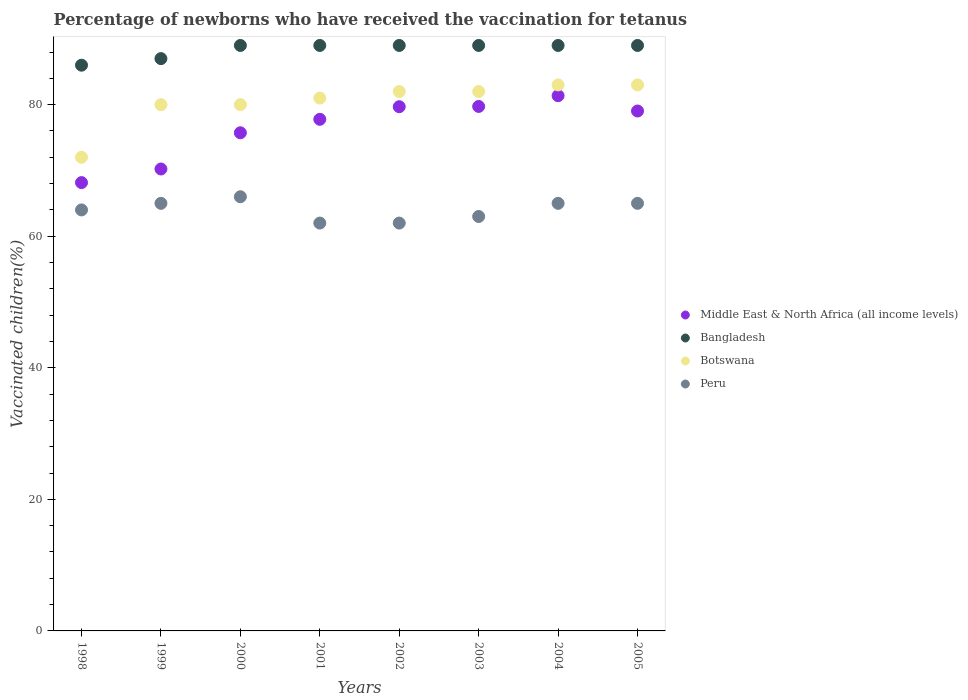What is the percentage of vaccinated children in Botswana in 2003?
Make the answer very short. 82. Across all years, what is the maximum percentage of vaccinated children in Bangladesh?
Make the answer very short. 89. Across all years, what is the minimum percentage of vaccinated children in Botswana?
Offer a terse response. 72. In which year was the percentage of vaccinated children in Peru maximum?
Make the answer very short. 2000. What is the total percentage of vaccinated children in Peru in the graph?
Your answer should be very brief. 512. What is the average percentage of vaccinated children in Peru per year?
Your response must be concise. 64. In the year 1999, what is the difference between the percentage of vaccinated children in Middle East & North Africa (all income levels) and percentage of vaccinated children in Bangladesh?
Give a very brief answer. -16.78. In how many years, is the percentage of vaccinated children in Middle East & North Africa (all income levels) greater than 64 %?
Provide a succinct answer. 8. What is the ratio of the percentage of vaccinated children in Middle East & North Africa (all income levels) in 2001 to that in 2005?
Provide a succinct answer. 0.98. Is the difference between the percentage of vaccinated children in Middle East & North Africa (all income levels) in 2000 and 2005 greater than the difference between the percentage of vaccinated children in Bangladesh in 2000 and 2005?
Provide a short and direct response. No. What is the difference between the highest and the lowest percentage of vaccinated children in Bangladesh?
Your response must be concise. 3. In how many years, is the percentage of vaccinated children in Peru greater than the average percentage of vaccinated children in Peru taken over all years?
Provide a short and direct response. 4. Does the percentage of vaccinated children in Botswana monotonically increase over the years?
Make the answer very short. No. Is the percentage of vaccinated children in Middle East & North Africa (all income levels) strictly less than the percentage of vaccinated children in Peru over the years?
Your answer should be very brief. No. How many dotlines are there?
Provide a short and direct response. 4. What is the difference between two consecutive major ticks on the Y-axis?
Provide a succinct answer. 20. Are the values on the major ticks of Y-axis written in scientific E-notation?
Your answer should be very brief. No. Where does the legend appear in the graph?
Ensure brevity in your answer.  Center right. How many legend labels are there?
Offer a very short reply. 4. What is the title of the graph?
Make the answer very short. Percentage of newborns who have received the vaccination for tetanus. Does "Ecuador" appear as one of the legend labels in the graph?
Provide a succinct answer. No. What is the label or title of the X-axis?
Offer a terse response. Years. What is the label or title of the Y-axis?
Your answer should be compact. Vaccinated children(%). What is the Vaccinated children(%) of Middle East & North Africa (all income levels) in 1998?
Your answer should be compact. 68.15. What is the Vaccinated children(%) in Peru in 1998?
Provide a succinct answer. 64. What is the Vaccinated children(%) in Middle East & North Africa (all income levels) in 1999?
Provide a succinct answer. 70.22. What is the Vaccinated children(%) in Bangladesh in 1999?
Give a very brief answer. 87. What is the Vaccinated children(%) of Middle East & North Africa (all income levels) in 2000?
Provide a succinct answer. 75.73. What is the Vaccinated children(%) of Bangladesh in 2000?
Your answer should be compact. 89. What is the Vaccinated children(%) of Middle East & North Africa (all income levels) in 2001?
Ensure brevity in your answer.  77.77. What is the Vaccinated children(%) in Bangladesh in 2001?
Your answer should be very brief. 89. What is the Vaccinated children(%) of Botswana in 2001?
Provide a succinct answer. 81. What is the Vaccinated children(%) in Middle East & North Africa (all income levels) in 2002?
Keep it short and to the point. 79.69. What is the Vaccinated children(%) in Bangladesh in 2002?
Offer a terse response. 89. What is the Vaccinated children(%) in Botswana in 2002?
Your response must be concise. 82. What is the Vaccinated children(%) of Middle East & North Africa (all income levels) in 2003?
Provide a short and direct response. 79.73. What is the Vaccinated children(%) in Bangladesh in 2003?
Make the answer very short. 89. What is the Vaccinated children(%) in Middle East & North Africa (all income levels) in 2004?
Keep it short and to the point. 81.36. What is the Vaccinated children(%) in Bangladesh in 2004?
Your response must be concise. 89. What is the Vaccinated children(%) in Botswana in 2004?
Provide a succinct answer. 83. What is the Vaccinated children(%) in Middle East & North Africa (all income levels) in 2005?
Keep it short and to the point. 79.04. What is the Vaccinated children(%) in Bangladesh in 2005?
Make the answer very short. 89. What is the Vaccinated children(%) in Peru in 2005?
Keep it short and to the point. 65. Across all years, what is the maximum Vaccinated children(%) of Middle East & North Africa (all income levels)?
Offer a very short reply. 81.36. Across all years, what is the maximum Vaccinated children(%) of Bangladesh?
Your answer should be compact. 89. Across all years, what is the maximum Vaccinated children(%) of Peru?
Make the answer very short. 66. Across all years, what is the minimum Vaccinated children(%) in Middle East & North Africa (all income levels)?
Your answer should be very brief. 68.15. Across all years, what is the minimum Vaccinated children(%) in Botswana?
Offer a very short reply. 72. Across all years, what is the minimum Vaccinated children(%) in Peru?
Provide a succinct answer. 62. What is the total Vaccinated children(%) in Middle East & North Africa (all income levels) in the graph?
Offer a very short reply. 611.69. What is the total Vaccinated children(%) in Bangladesh in the graph?
Make the answer very short. 707. What is the total Vaccinated children(%) in Botswana in the graph?
Your answer should be compact. 643. What is the total Vaccinated children(%) of Peru in the graph?
Your answer should be compact. 512. What is the difference between the Vaccinated children(%) in Middle East & North Africa (all income levels) in 1998 and that in 1999?
Offer a very short reply. -2.07. What is the difference between the Vaccinated children(%) in Peru in 1998 and that in 1999?
Your answer should be very brief. -1. What is the difference between the Vaccinated children(%) of Middle East & North Africa (all income levels) in 1998 and that in 2000?
Provide a succinct answer. -7.57. What is the difference between the Vaccinated children(%) of Bangladesh in 1998 and that in 2000?
Keep it short and to the point. -3. What is the difference between the Vaccinated children(%) in Peru in 1998 and that in 2000?
Keep it short and to the point. -2. What is the difference between the Vaccinated children(%) of Middle East & North Africa (all income levels) in 1998 and that in 2001?
Offer a terse response. -9.62. What is the difference between the Vaccinated children(%) of Bangladesh in 1998 and that in 2001?
Offer a terse response. -3. What is the difference between the Vaccinated children(%) in Peru in 1998 and that in 2001?
Your answer should be very brief. 2. What is the difference between the Vaccinated children(%) of Middle East & North Africa (all income levels) in 1998 and that in 2002?
Keep it short and to the point. -11.54. What is the difference between the Vaccinated children(%) of Peru in 1998 and that in 2002?
Provide a short and direct response. 2. What is the difference between the Vaccinated children(%) of Middle East & North Africa (all income levels) in 1998 and that in 2003?
Keep it short and to the point. -11.58. What is the difference between the Vaccinated children(%) of Bangladesh in 1998 and that in 2003?
Ensure brevity in your answer.  -3. What is the difference between the Vaccinated children(%) in Peru in 1998 and that in 2003?
Give a very brief answer. 1. What is the difference between the Vaccinated children(%) in Middle East & North Africa (all income levels) in 1998 and that in 2004?
Keep it short and to the point. -13.21. What is the difference between the Vaccinated children(%) of Middle East & North Africa (all income levels) in 1998 and that in 2005?
Offer a terse response. -10.89. What is the difference between the Vaccinated children(%) in Bangladesh in 1998 and that in 2005?
Ensure brevity in your answer.  -3. What is the difference between the Vaccinated children(%) in Botswana in 1998 and that in 2005?
Offer a very short reply. -11. What is the difference between the Vaccinated children(%) in Middle East & North Africa (all income levels) in 1999 and that in 2000?
Give a very brief answer. -5.5. What is the difference between the Vaccinated children(%) in Bangladesh in 1999 and that in 2000?
Your answer should be very brief. -2. What is the difference between the Vaccinated children(%) in Peru in 1999 and that in 2000?
Your answer should be compact. -1. What is the difference between the Vaccinated children(%) in Middle East & North Africa (all income levels) in 1999 and that in 2001?
Provide a succinct answer. -7.55. What is the difference between the Vaccinated children(%) in Bangladesh in 1999 and that in 2001?
Offer a very short reply. -2. What is the difference between the Vaccinated children(%) of Botswana in 1999 and that in 2001?
Your answer should be compact. -1. What is the difference between the Vaccinated children(%) of Peru in 1999 and that in 2001?
Your response must be concise. 3. What is the difference between the Vaccinated children(%) of Middle East & North Africa (all income levels) in 1999 and that in 2002?
Give a very brief answer. -9.47. What is the difference between the Vaccinated children(%) of Bangladesh in 1999 and that in 2002?
Ensure brevity in your answer.  -2. What is the difference between the Vaccinated children(%) in Botswana in 1999 and that in 2002?
Your answer should be very brief. -2. What is the difference between the Vaccinated children(%) of Middle East & North Africa (all income levels) in 1999 and that in 2003?
Ensure brevity in your answer.  -9.51. What is the difference between the Vaccinated children(%) in Bangladesh in 1999 and that in 2003?
Make the answer very short. -2. What is the difference between the Vaccinated children(%) in Middle East & North Africa (all income levels) in 1999 and that in 2004?
Provide a succinct answer. -11.14. What is the difference between the Vaccinated children(%) in Bangladesh in 1999 and that in 2004?
Provide a short and direct response. -2. What is the difference between the Vaccinated children(%) in Botswana in 1999 and that in 2004?
Offer a terse response. -3. What is the difference between the Vaccinated children(%) of Peru in 1999 and that in 2004?
Your answer should be compact. 0. What is the difference between the Vaccinated children(%) of Middle East & North Africa (all income levels) in 1999 and that in 2005?
Your answer should be compact. -8.82. What is the difference between the Vaccinated children(%) in Botswana in 1999 and that in 2005?
Keep it short and to the point. -3. What is the difference between the Vaccinated children(%) of Peru in 1999 and that in 2005?
Give a very brief answer. 0. What is the difference between the Vaccinated children(%) in Middle East & North Africa (all income levels) in 2000 and that in 2001?
Give a very brief answer. -2.05. What is the difference between the Vaccinated children(%) in Bangladesh in 2000 and that in 2001?
Your answer should be very brief. 0. What is the difference between the Vaccinated children(%) in Middle East & North Africa (all income levels) in 2000 and that in 2002?
Make the answer very short. -3.96. What is the difference between the Vaccinated children(%) of Botswana in 2000 and that in 2002?
Offer a terse response. -2. What is the difference between the Vaccinated children(%) of Peru in 2000 and that in 2002?
Provide a short and direct response. 4. What is the difference between the Vaccinated children(%) in Middle East & North Africa (all income levels) in 2000 and that in 2003?
Your answer should be compact. -4. What is the difference between the Vaccinated children(%) in Bangladesh in 2000 and that in 2003?
Your response must be concise. 0. What is the difference between the Vaccinated children(%) in Middle East & North Africa (all income levels) in 2000 and that in 2004?
Keep it short and to the point. -5.64. What is the difference between the Vaccinated children(%) in Middle East & North Africa (all income levels) in 2000 and that in 2005?
Provide a succinct answer. -3.31. What is the difference between the Vaccinated children(%) of Bangladesh in 2000 and that in 2005?
Provide a short and direct response. 0. What is the difference between the Vaccinated children(%) in Botswana in 2000 and that in 2005?
Provide a short and direct response. -3. What is the difference between the Vaccinated children(%) of Peru in 2000 and that in 2005?
Your answer should be compact. 1. What is the difference between the Vaccinated children(%) of Middle East & North Africa (all income levels) in 2001 and that in 2002?
Your answer should be very brief. -1.92. What is the difference between the Vaccinated children(%) of Peru in 2001 and that in 2002?
Make the answer very short. 0. What is the difference between the Vaccinated children(%) in Middle East & North Africa (all income levels) in 2001 and that in 2003?
Provide a succinct answer. -1.96. What is the difference between the Vaccinated children(%) of Bangladesh in 2001 and that in 2003?
Offer a terse response. 0. What is the difference between the Vaccinated children(%) in Botswana in 2001 and that in 2003?
Provide a succinct answer. -1. What is the difference between the Vaccinated children(%) in Peru in 2001 and that in 2003?
Give a very brief answer. -1. What is the difference between the Vaccinated children(%) in Middle East & North Africa (all income levels) in 2001 and that in 2004?
Your response must be concise. -3.59. What is the difference between the Vaccinated children(%) in Bangladesh in 2001 and that in 2004?
Your answer should be compact. 0. What is the difference between the Vaccinated children(%) in Botswana in 2001 and that in 2004?
Offer a terse response. -2. What is the difference between the Vaccinated children(%) in Peru in 2001 and that in 2004?
Your answer should be very brief. -3. What is the difference between the Vaccinated children(%) of Middle East & North Africa (all income levels) in 2001 and that in 2005?
Offer a terse response. -1.26. What is the difference between the Vaccinated children(%) of Botswana in 2001 and that in 2005?
Provide a short and direct response. -2. What is the difference between the Vaccinated children(%) of Middle East & North Africa (all income levels) in 2002 and that in 2003?
Keep it short and to the point. -0.04. What is the difference between the Vaccinated children(%) in Bangladesh in 2002 and that in 2003?
Your answer should be very brief. 0. What is the difference between the Vaccinated children(%) of Middle East & North Africa (all income levels) in 2002 and that in 2004?
Provide a succinct answer. -1.68. What is the difference between the Vaccinated children(%) in Bangladesh in 2002 and that in 2004?
Your answer should be very brief. 0. What is the difference between the Vaccinated children(%) in Peru in 2002 and that in 2004?
Provide a succinct answer. -3. What is the difference between the Vaccinated children(%) of Middle East & North Africa (all income levels) in 2002 and that in 2005?
Your response must be concise. 0.65. What is the difference between the Vaccinated children(%) of Bangladesh in 2002 and that in 2005?
Your answer should be compact. 0. What is the difference between the Vaccinated children(%) in Botswana in 2002 and that in 2005?
Offer a very short reply. -1. What is the difference between the Vaccinated children(%) of Peru in 2002 and that in 2005?
Ensure brevity in your answer.  -3. What is the difference between the Vaccinated children(%) of Middle East & North Africa (all income levels) in 2003 and that in 2004?
Ensure brevity in your answer.  -1.64. What is the difference between the Vaccinated children(%) in Botswana in 2003 and that in 2004?
Offer a terse response. -1. What is the difference between the Vaccinated children(%) of Peru in 2003 and that in 2004?
Offer a very short reply. -2. What is the difference between the Vaccinated children(%) in Middle East & North Africa (all income levels) in 2003 and that in 2005?
Your response must be concise. 0.69. What is the difference between the Vaccinated children(%) of Bangladesh in 2003 and that in 2005?
Keep it short and to the point. 0. What is the difference between the Vaccinated children(%) in Peru in 2003 and that in 2005?
Give a very brief answer. -2. What is the difference between the Vaccinated children(%) of Middle East & North Africa (all income levels) in 2004 and that in 2005?
Ensure brevity in your answer.  2.33. What is the difference between the Vaccinated children(%) of Botswana in 2004 and that in 2005?
Your answer should be compact. 0. What is the difference between the Vaccinated children(%) in Middle East & North Africa (all income levels) in 1998 and the Vaccinated children(%) in Bangladesh in 1999?
Your answer should be very brief. -18.85. What is the difference between the Vaccinated children(%) of Middle East & North Africa (all income levels) in 1998 and the Vaccinated children(%) of Botswana in 1999?
Offer a terse response. -11.85. What is the difference between the Vaccinated children(%) of Middle East & North Africa (all income levels) in 1998 and the Vaccinated children(%) of Peru in 1999?
Give a very brief answer. 3.15. What is the difference between the Vaccinated children(%) in Bangladesh in 1998 and the Vaccinated children(%) in Botswana in 1999?
Ensure brevity in your answer.  6. What is the difference between the Vaccinated children(%) in Bangladesh in 1998 and the Vaccinated children(%) in Peru in 1999?
Keep it short and to the point. 21. What is the difference between the Vaccinated children(%) of Middle East & North Africa (all income levels) in 1998 and the Vaccinated children(%) of Bangladesh in 2000?
Make the answer very short. -20.85. What is the difference between the Vaccinated children(%) of Middle East & North Africa (all income levels) in 1998 and the Vaccinated children(%) of Botswana in 2000?
Provide a succinct answer. -11.85. What is the difference between the Vaccinated children(%) of Middle East & North Africa (all income levels) in 1998 and the Vaccinated children(%) of Peru in 2000?
Provide a short and direct response. 2.15. What is the difference between the Vaccinated children(%) in Bangladesh in 1998 and the Vaccinated children(%) in Botswana in 2000?
Your answer should be compact. 6. What is the difference between the Vaccinated children(%) of Bangladesh in 1998 and the Vaccinated children(%) of Peru in 2000?
Offer a terse response. 20. What is the difference between the Vaccinated children(%) of Botswana in 1998 and the Vaccinated children(%) of Peru in 2000?
Your response must be concise. 6. What is the difference between the Vaccinated children(%) in Middle East & North Africa (all income levels) in 1998 and the Vaccinated children(%) in Bangladesh in 2001?
Your response must be concise. -20.85. What is the difference between the Vaccinated children(%) in Middle East & North Africa (all income levels) in 1998 and the Vaccinated children(%) in Botswana in 2001?
Ensure brevity in your answer.  -12.85. What is the difference between the Vaccinated children(%) in Middle East & North Africa (all income levels) in 1998 and the Vaccinated children(%) in Peru in 2001?
Offer a very short reply. 6.15. What is the difference between the Vaccinated children(%) of Bangladesh in 1998 and the Vaccinated children(%) of Botswana in 2001?
Give a very brief answer. 5. What is the difference between the Vaccinated children(%) in Middle East & North Africa (all income levels) in 1998 and the Vaccinated children(%) in Bangladesh in 2002?
Offer a terse response. -20.85. What is the difference between the Vaccinated children(%) of Middle East & North Africa (all income levels) in 1998 and the Vaccinated children(%) of Botswana in 2002?
Your response must be concise. -13.85. What is the difference between the Vaccinated children(%) of Middle East & North Africa (all income levels) in 1998 and the Vaccinated children(%) of Peru in 2002?
Offer a terse response. 6.15. What is the difference between the Vaccinated children(%) in Bangladesh in 1998 and the Vaccinated children(%) in Botswana in 2002?
Your response must be concise. 4. What is the difference between the Vaccinated children(%) of Bangladesh in 1998 and the Vaccinated children(%) of Peru in 2002?
Provide a short and direct response. 24. What is the difference between the Vaccinated children(%) of Botswana in 1998 and the Vaccinated children(%) of Peru in 2002?
Give a very brief answer. 10. What is the difference between the Vaccinated children(%) of Middle East & North Africa (all income levels) in 1998 and the Vaccinated children(%) of Bangladesh in 2003?
Your response must be concise. -20.85. What is the difference between the Vaccinated children(%) of Middle East & North Africa (all income levels) in 1998 and the Vaccinated children(%) of Botswana in 2003?
Keep it short and to the point. -13.85. What is the difference between the Vaccinated children(%) in Middle East & North Africa (all income levels) in 1998 and the Vaccinated children(%) in Peru in 2003?
Provide a succinct answer. 5.15. What is the difference between the Vaccinated children(%) of Bangladesh in 1998 and the Vaccinated children(%) of Botswana in 2003?
Make the answer very short. 4. What is the difference between the Vaccinated children(%) of Bangladesh in 1998 and the Vaccinated children(%) of Peru in 2003?
Provide a short and direct response. 23. What is the difference between the Vaccinated children(%) of Botswana in 1998 and the Vaccinated children(%) of Peru in 2003?
Keep it short and to the point. 9. What is the difference between the Vaccinated children(%) of Middle East & North Africa (all income levels) in 1998 and the Vaccinated children(%) of Bangladesh in 2004?
Ensure brevity in your answer.  -20.85. What is the difference between the Vaccinated children(%) of Middle East & North Africa (all income levels) in 1998 and the Vaccinated children(%) of Botswana in 2004?
Keep it short and to the point. -14.85. What is the difference between the Vaccinated children(%) in Middle East & North Africa (all income levels) in 1998 and the Vaccinated children(%) in Peru in 2004?
Offer a terse response. 3.15. What is the difference between the Vaccinated children(%) of Bangladesh in 1998 and the Vaccinated children(%) of Botswana in 2004?
Keep it short and to the point. 3. What is the difference between the Vaccinated children(%) in Botswana in 1998 and the Vaccinated children(%) in Peru in 2004?
Ensure brevity in your answer.  7. What is the difference between the Vaccinated children(%) of Middle East & North Africa (all income levels) in 1998 and the Vaccinated children(%) of Bangladesh in 2005?
Your answer should be very brief. -20.85. What is the difference between the Vaccinated children(%) in Middle East & North Africa (all income levels) in 1998 and the Vaccinated children(%) in Botswana in 2005?
Your answer should be compact. -14.85. What is the difference between the Vaccinated children(%) in Middle East & North Africa (all income levels) in 1998 and the Vaccinated children(%) in Peru in 2005?
Make the answer very short. 3.15. What is the difference between the Vaccinated children(%) of Middle East & North Africa (all income levels) in 1999 and the Vaccinated children(%) of Bangladesh in 2000?
Ensure brevity in your answer.  -18.78. What is the difference between the Vaccinated children(%) in Middle East & North Africa (all income levels) in 1999 and the Vaccinated children(%) in Botswana in 2000?
Your response must be concise. -9.78. What is the difference between the Vaccinated children(%) of Middle East & North Africa (all income levels) in 1999 and the Vaccinated children(%) of Peru in 2000?
Make the answer very short. 4.22. What is the difference between the Vaccinated children(%) in Bangladesh in 1999 and the Vaccinated children(%) in Peru in 2000?
Offer a very short reply. 21. What is the difference between the Vaccinated children(%) in Middle East & North Africa (all income levels) in 1999 and the Vaccinated children(%) in Bangladesh in 2001?
Provide a succinct answer. -18.78. What is the difference between the Vaccinated children(%) of Middle East & North Africa (all income levels) in 1999 and the Vaccinated children(%) of Botswana in 2001?
Your answer should be compact. -10.78. What is the difference between the Vaccinated children(%) in Middle East & North Africa (all income levels) in 1999 and the Vaccinated children(%) in Peru in 2001?
Your answer should be very brief. 8.22. What is the difference between the Vaccinated children(%) of Botswana in 1999 and the Vaccinated children(%) of Peru in 2001?
Your answer should be very brief. 18. What is the difference between the Vaccinated children(%) in Middle East & North Africa (all income levels) in 1999 and the Vaccinated children(%) in Bangladesh in 2002?
Your response must be concise. -18.78. What is the difference between the Vaccinated children(%) of Middle East & North Africa (all income levels) in 1999 and the Vaccinated children(%) of Botswana in 2002?
Give a very brief answer. -11.78. What is the difference between the Vaccinated children(%) in Middle East & North Africa (all income levels) in 1999 and the Vaccinated children(%) in Peru in 2002?
Offer a very short reply. 8.22. What is the difference between the Vaccinated children(%) in Botswana in 1999 and the Vaccinated children(%) in Peru in 2002?
Offer a very short reply. 18. What is the difference between the Vaccinated children(%) of Middle East & North Africa (all income levels) in 1999 and the Vaccinated children(%) of Bangladesh in 2003?
Provide a short and direct response. -18.78. What is the difference between the Vaccinated children(%) of Middle East & North Africa (all income levels) in 1999 and the Vaccinated children(%) of Botswana in 2003?
Make the answer very short. -11.78. What is the difference between the Vaccinated children(%) of Middle East & North Africa (all income levels) in 1999 and the Vaccinated children(%) of Peru in 2003?
Your response must be concise. 7.22. What is the difference between the Vaccinated children(%) in Bangladesh in 1999 and the Vaccinated children(%) in Botswana in 2003?
Provide a succinct answer. 5. What is the difference between the Vaccinated children(%) in Bangladesh in 1999 and the Vaccinated children(%) in Peru in 2003?
Your answer should be very brief. 24. What is the difference between the Vaccinated children(%) in Middle East & North Africa (all income levels) in 1999 and the Vaccinated children(%) in Bangladesh in 2004?
Keep it short and to the point. -18.78. What is the difference between the Vaccinated children(%) in Middle East & North Africa (all income levels) in 1999 and the Vaccinated children(%) in Botswana in 2004?
Your response must be concise. -12.78. What is the difference between the Vaccinated children(%) in Middle East & North Africa (all income levels) in 1999 and the Vaccinated children(%) in Peru in 2004?
Offer a very short reply. 5.22. What is the difference between the Vaccinated children(%) in Bangladesh in 1999 and the Vaccinated children(%) in Botswana in 2004?
Keep it short and to the point. 4. What is the difference between the Vaccinated children(%) in Bangladesh in 1999 and the Vaccinated children(%) in Peru in 2004?
Keep it short and to the point. 22. What is the difference between the Vaccinated children(%) of Middle East & North Africa (all income levels) in 1999 and the Vaccinated children(%) of Bangladesh in 2005?
Your response must be concise. -18.78. What is the difference between the Vaccinated children(%) of Middle East & North Africa (all income levels) in 1999 and the Vaccinated children(%) of Botswana in 2005?
Your answer should be compact. -12.78. What is the difference between the Vaccinated children(%) of Middle East & North Africa (all income levels) in 1999 and the Vaccinated children(%) of Peru in 2005?
Provide a succinct answer. 5.22. What is the difference between the Vaccinated children(%) of Bangladesh in 1999 and the Vaccinated children(%) of Botswana in 2005?
Your answer should be compact. 4. What is the difference between the Vaccinated children(%) in Bangladesh in 1999 and the Vaccinated children(%) in Peru in 2005?
Your answer should be very brief. 22. What is the difference between the Vaccinated children(%) of Middle East & North Africa (all income levels) in 2000 and the Vaccinated children(%) of Bangladesh in 2001?
Provide a short and direct response. -13.27. What is the difference between the Vaccinated children(%) in Middle East & North Africa (all income levels) in 2000 and the Vaccinated children(%) in Botswana in 2001?
Provide a short and direct response. -5.27. What is the difference between the Vaccinated children(%) of Middle East & North Africa (all income levels) in 2000 and the Vaccinated children(%) of Peru in 2001?
Offer a very short reply. 13.73. What is the difference between the Vaccinated children(%) in Bangladesh in 2000 and the Vaccinated children(%) in Botswana in 2001?
Give a very brief answer. 8. What is the difference between the Vaccinated children(%) of Botswana in 2000 and the Vaccinated children(%) of Peru in 2001?
Offer a terse response. 18. What is the difference between the Vaccinated children(%) in Middle East & North Africa (all income levels) in 2000 and the Vaccinated children(%) in Bangladesh in 2002?
Provide a succinct answer. -13.27. What is the difference between the Vaccinated children(%) in Middle East & North Africa (all income levels) in 2000 and the Vaccinated children(%) in Botswana in 2002?
Provide a succinct answer. -6.27. What is the difference between the Vaccinated children(%) of Middle East & North Africa (all income levels) in 2000 and the Vaccinated children(%) of Peru in 2002?
Provide a short and direct response. 13.73. What is the difference between the Vaccinated children(%) of Bangladesh in 2000 and the Vaccinated children(%) of Botswana in 2002?
Your answer should be compact. 7. What is the difference between the Vaccinated children(%) of Bangladesh in 2000 and the Vaccinated children(%) of Peru in 2002?
Ensure brevity in your answer.  27. What is the difference between the Vaccinated children(%) in Botswana in 2000 and the Vaccinated children(%) in Peru in 2002?
Ensure brevity in your answer.  18. What is the difference between the Vaccinated children(%) in Middle East & North Africa (all income levels) in 2000 and the Vaccinated children(%) in Bangladesh in 2003?
Your answer should be compact. -13.27. What is the difference between the Vaccinated children(%) of Middle East & North Africa (all income levels) in 2000 and the Vaccinated children(%) of Botswana in 2003?
Offer a terse response. -6.27. What is the difference between the Vaccinated children(%) in Middle East & North Africa (all income levels) in 2000 and the Vaccinated children(%) in Peru in 2003?
Ensure brevity in your answer.  12.73. What is the difference between the Vaccinated children(%) in Bangladesh in 2000 and the Vaccinated children(%) in Botswana in 2003?
Your answer should be very brief. 7. What is the difference between the Vaccinated children(%) of Bangladesh in 2000 and the Vaccinated children(%) of Peru in 2003?
Keep it short and to the point. 26. What is the difference between the Vaccinated children(%) of Middle East & North Africa (all income levels) in 2000 and the Vaccinated children(%) of Bangladesh in 2004?
Provide a succinct answer. -13.27. What is the difference between the Vaccinated children(%) of Middle East & North Africa (all income levels) in 2000 and the Vaccinated children(%) of Botswana in 2004?
Keep it short and to the point. -7.27. What is the difference between the Vaccinated children(%) of Middle East & North Africa (all income levels) in 2000 and the Vaccinated children(%) of Peru in 2004?
Offer a terse response. 10.73. What is the difference between the Vaccinated children(%) of Botswana in 2000 and the Vaccinated children(%) of Peru in 2004?
Your answer should be compact. 15. What is the difference between the Vaccinated children(%) of Middle East & North Africa (all income levels) in 2000 and the Vaccinated children(%) of Bangladesh in 2005?
Your response must be concise. -13.27. What is the difference between the Vaccinated children(%) in Middle East & North Africa (all income levels) in 2000 and the Vaccinated children(%) in Botswana in 2005?
Give a very brief answer. -7.27. What is the difference between the Vaccinated children(%) of Middle East & North Africa (all income levels) in 2000 and the Vaccinated children(%) of Peru in 2005?
Ensure brevity in your answer.  10.73. What is the difference between the Vaccinated children(%) in Middle East & North Africa (all income levels) in 2001 and the Vaccinated children(%) in Bangladesh in 2002?
Offer a terse response. -11.23. What is the difference between the Vaccinated children(%) in Middle East & North Africa (all income levels) in 2001 and the Vaccinated children(%) in Botswana in 2002?
Ensure brevity in your answer.  -4.23. What is the difference between the Vaccinated children(%) of Middle East & North Africa (all income levels) in 2001 and the Vaccinated children(%) of Peru in 2002?
Offer a terse response. 15.77. What is the difference between the Vaccinated children(%) in Bangladesh in 2001 and the Vaccinated children(%) in Peru in 2002?
Make the answer very short. 27. What is the difference between the Vaccinated children(%) in Middle East & North Africa (all income levels) in 2001 and the Vaccinated children(%) in Bangladesh in 2003?
Ensure brevity in your answer.  -11.23. What is the difference between the Vaccinated children(%) in Middle East & North Africa (all income levels) in 2001 and the Vaccinated children(%) in Botswana in 2003?
Provide a short and direct response. -4.23. What is the difference between the Vaccinated children(%) in Middle East & North Africa (all income levels) in 2001 and the Vaccinated children(%) in Peru in 2003?
Provide a short and direct response. 14.77. What is the difference between the Vaccinated children(%) in Bangladesh in 2001 and the Vaccinated children(%) in Botswana in 2003?
Provide a short and direct response. 7. What is the difference between the Vaccinated children(%) of Bangladesh in 2001 and the Vaccinated children(%) of Peru in 2003?
Ensure brevity in your answer.  26. What is the difference between the Vaccinated children(%) in Botswana in 2001 and the Vaccinated children(%) in Peru in 2003?
Give a very brief answer. 18. What is the difference between the Vaccinated children(%) in Middle East & North Africa (all income levels) in 2001 and the Vaccinated children(%) in Bangladesh in 2004?
Make the answer very short. -11.23. What is the difference between the Vaccinated children(%) of Middle East & North Africa (all income levels) in 2001 and the Vaccinated children(%) of Botswana in 2004?
Offer a terse response. -5.23. What is the difference between the Vaccinated children(%) of Middle East & North Africa (all income levels) in 2001 and the Vaccinated children(%) of Peru in 2004?
Provide a short and direct response. 12.77. What is the difference between the Vaccinated children(%) in Middle East & North Africa (all income levels) in 2001 and the Vaccinated children(%) in Bangladesh in 2005?
Offer a terse response. -11.23. What is the difference between the Vaccinated children(%) of Middle East & North Africa (all income levels) in 2001 and the Vaccinated children(%) of Botswana in 2005?
Your response must be concise. -5.23. What is the difference between the Vaccinated children(%) of Middle East & North Africa (all income levels) in 2001 and the Vaccinated children(%) of Peru in 2005?
Your answer should be compact. 12.77. What is the difference between the Vaccinated children(%) in Bangladesh in 2001 and the Vaccinated children(%) in Botswana in 2005?
Make the answer very short. 6. What is the difference between the Vaccinated children(%) in Botswana in 2001 and the Vaccinated children(%) in Peru in 2005?
Keep it short and to the point. 16. What is the difference between the Vaccinated children(%) in Middle East & North Africa (all income levels) in 2002 and the Vaccinated children(%) in Bangladesh in 2003?
Give a very brief answer. -9.31. What is the difference between the Vaccinated children(%) in Middle East & North Africa (all income levels) in 2002 and the Vaccinated children(%) in Botswana in 2003?
Offer a terse response. -2.31. What is the difference between the Vaccinated children(%) of Middle East & North Africa (all income levels) in 2002 and the Vaccinated children(%) of Peru in 2003?
Offer a terse response. 16.69. What is the difference between the Vaccinated children(%) of Bangladesh in 2002 and the Vaccinated children(%) of Botswana in 2003?
Provide a succinct answer. 7. What is the difference between the Vaccinated children(%) in Bangladesh in 2002 and the Vaccinated children(%) in Peru in 2003?
Offer a very short reply. 26. What is the difference between the Vaccinated children(%) in Botswana in 2002 and the Vaccinated children(%) in Peru in 2003?
Your response must be concise. 19. What is the difference between the Vaccinated children(%) of Middle East & North Africa (all income levels) in 2002 and the Vaccinated children(%) of Bangladesh in 2004?
Offer a very short reply. -9.31. What is the difference between the Vaccinated children(%) of Middle East & North Africa (all income levels) in 2002 and the Vaccinated children(%) of Botswana in 2004?
Provide a short and direct response. -3.31. What is the difference between the Vaccinated children(%) in Middle East & North Africa (all income levels) in 2002 and the Vaccinated children(%) in Peru in 2004?
Offer a terse response. 14.69. What is the difference between the Vaccinated children(%) of Bangladesh in 2002 and the Vaccinated children(%) of Botswana in 2004?
Provide a short and direct response. 6. What is the difference between the Vaccinated children(%) of Bangladesh in 2002 and the Vaccinated children(%) of Peru in 2004?
Provide a short and direct response. 24. What is the difference between the Vaccinated children(%) of Middle East & North Africa (all income levels) in 2002 and the Vaccinated children(%) of Bangladesh in 2005?
Make the answer very short. -9.31. What is the difference between the Vaccinated children(%) in Middle East & North Africa (all income levels) in 2002 and the Vaccinated children(%) in Botswana in 2005?
Keep it short and to the point. -3.31. What is the difference between the Vaccinated children(%) in Middle East & North Africa (all income levels) in 2002 and the Vaccinated children(%) in Peru in 2005?
Provide a short and direct response. 14.69. What is the difference between the Vaccinated children(%) in Middle East & North Africa (all income levels) in 2003 and the Vaccinated children(%) in Bangladesh in 2004?
Provide a succinct answer. -9.27. What is the difference between the Vaccinated children(%) in Middle East & North Africa (all income levels) in 2003 and the Vaccinated children(%) in Botswana in 2004?
Provide a succinct answer. -3.27. What is the difference between the Vaccinated children(%) in Middle East & North Africa (all income levels) in 2003 and the Vaccinated children(%) in Peru in 2004?
Give a very brief answer. 14.73. What is the difference between the Vaccinated children(%) of Bangladesh in 2003 and the Vaccinated children(%) of Botswana in 2004?
Keep it short and to the point. 6. What is the difference between the Vaccinated children(%) in Bangladesh in 2003 and the Vaccinated children(%) in Peru in 2004?
Your answer should be compact. 24. What is the difference between the Vaccinated children(%) in Botswana in 2003 and the Vaccinated children(%) in Peru in 2004?
Your answer should be very brief. 17. What is the difference between the Vaccinated children(%) in Middle East & North Africa (all income levels) in 2003 and the Vaccinated children(%) in Bangladesh in 2005?
Offer a very short reply. -9.27. What is the difference between the Vaccinated children(%) in Middle East & North Africa (all income levels) in 2003 and the Vaccinated children(%) in Botswana in 2005?
Make the answer very short. -3.27. What is the difference between the Vaccinated children(%) in Middle East & North Africa (all income levels) in 2003 and the Vaccinated children(%) in Peru in 2005?
Your response must be concise. 14.73. What is the difference between the Vaccinated children(%) in Bangladesh in 2003 and the Vaccinated children(%) in Botswana in 2005?
Ensure brevity in your answer.  6. What is the difference between the Vaccinated children(%) in Middle East & North Africa (all income levels) in 2004 and the Vaccinated children(%) in Bangladesh in 2005?
Make the answer very short. -7.64. What is the difference between the Vaccinated children(%) in Middle East & North Africa (all income levels) in 2004 and the Vaccinated children(%) in Botswana in 2005?
Make the answer very short. -1.64. What is the difference between the Vaccinated children(%) in Middle East & North Africa (all income levels) in 2004 and the Vaccinated children(%) in Peru in 2005?
Keep it short and to the point. 16.36. What is the difference between the Vaccinated children(%) in Bangladesh in 2004 and the Vaccinated children(%) in Botswana in 2005?
Make the answer very short. 6. What is the difference between the Vaccinated children(%) in Bangladesh in 2004 and the Vaccinated children(%) in Peru in 2005?
Provide a succinct answer. 24. What is the average Vaccinated children(%) of Middle East & North Africa (all income levels) per year?
Your answer should be compact. 76.46. What is the average Vaccinated children(%) of Bangladesh per year?
Ensure brevity in your answer.  88.38. What is the average Vaccinated children(%) of Botswana per year?
Your answer should be compact. 80.38. In the year 1998, what is the difference between the Vaccinated children(%) of Middle East & North Africa (all income levels) and Vaccinated children(%) of Bangladesh?
Ensure brevity in your answer.  -17.85. In the year 1998, what is the difference between the Vaccinated children(%) of Middle East & North Africa (all income levels) and Vaccinated children(%) of Botswana?
Your answer should be very brief. -3.85. In the year 1998, what is the difference between the Vaccinated children(%) of Middle East & North Africa (all income levels) and Vaccinated children(%) of Peru?
Offer a very short reply. 4.15. In the year 1998, what is the difference between the Vaccinated children(%) in Bangladesh and Vaccinated children(%) in Peru?
Make the answer very short. 22. In the year 1999, what is the difference between the Vaccinated children(%) in Middle East & North Africa (all income levels) and Vaccinated children(%) in Bangladesh?
Keep it short and to the point. -16.78. In the year 1999, what is the difference between the Vaccinated children(%) of Middle East & North Africa (all income levels) and Vaccinated children(%) of Botswana?
Give a very brief answer. -9.78. In the year 1999, what is the difference between the Vaccinated children(%) in Middle East & North Africa (all income levels) and Vaccinated children(%) in Peru?
Keep it short and to the point. 5.22. In the year 1999, what is the difference between the Vaccinated children(%) in Bangladesh and Vaccinated children(%) in Botswana?
Your answer should be very brief. 7. In the year 1999, what is the difference between the Vaccinated children(%) of Bangladesh and Vaccinated children(%) of Peru?
Provide a succinct answer. 22. In the year 2000, what is the difference between the Vaccinated children(%) in Middle East & North Africa (all income levels) and Vaccinated children(%) in Bangladesh?
Provide a succinct answer. -13.27. In the year 2000, what is the difference between the Vaccinated children(%) of Middle East & North Africa (all income levels) and Vaccinated children(%) of Botswana?
Make the answer very short. -4.27. In the year 2000, what is the difference between the Vaccinated children(%) in Middle East & North Africa (all income levels) and Vaccinated children(%) in Peru?
Ensure brevity in your answer.  9.73. In the year 2000, what is the difference between the Vaccinated children(%) of Bangladesh and Vaccinated children(%) of Peru?
Ensure brevity in your answer.  23. In the year 2000, what is the difference between the Vaccinated children(%) of Botswana and Vaccinated children(%) of Peru?
Your answer should be very brief. 14. In the year 2001, what is the difference between the Vaccinated children(%) of Middle East & North Africa (all income levels) and Vaccinated children(%) of Bangladesh?
Give a very brief answer. -11.23. In the year 2001, what is the difference between the Vaccinated children(%) in Middle East & North Africa (all income levels) and Vaccinated children(%) in Botswana?
Ensure brevity in your answer.  -3.23. In the year 2001, what is the difference between the Vaccinated children(%) in Middle East & North Africa (all income levels) and Vaccinated children(%) in Peru?
Give a very brief answer. 15.77. In the year 2001, what is the difference between the Vaccinated children(%) in Bangladesh and Vaccinated children(%) in Peru?
Give a very brief answer. 27. In the year 2001, what is the difference between the Vaccinated children(%) in Botswana and Vaccinated children(%) in Peru?
Your answer should be very brief. 19. In the year 2002, what is the difference between the Vaccinated children(%) of Middle East & North Africa (all income levels) and Vaccinated children(%) of Bangladesh?
Provide a succinct answer. -9.31. In the year 2002, what is the difference between the Vaccinated children(%) in Middle East & North Africa (all income levels) and Vaccinated children(%) in Botswana?
Give a very brief answer. -2.31. In the year 2002, what is the difference between the Vaccinated children(%) of Middle East & North Africa (all income levels) and Vaccinated children(%) of Peru?
Give a very brief answer. 17.69. In the year 2002, what is the difference between the Vaccinated children(%) of Bangladesh and Vaccinated children(%) of Peru?
Give a very brief answer. 27. In the year 2003, what is the difference between the Vaccinated children(%) of Middle East & North Africa (all income levels) and Vaccinated children(%) of Bangladesh?
Make the answer very short. -9.27. In the year 2003, what is the difference between the Vaccinated children(%) of Middle East & North Africa (all income levels) and Vaccinated children(%) of Botswana?
Make the answer very short. -2.27. In the year 2003, what is the difference between the Vaccinated children(%) of Middle East & North Africa (all income levels) and Vaccinated children(%) of Peru?
Make the answer very short. 16.73. In the year 2004, what is the difference between the Vaccinated children(%) in Middle East & North Africa (all income levels) and Vaccinated children(%) in Bangladesh?
Your response must be concise. -7.64. In the year 2004, what is the difference between the Vaccinated children(%) of Middle East & North Africa (all income levels) and Vaccinated children(%) of Botswana?
Your answer should be very brief. -1.64. In the year 2004, what is the difference between the Vaccinated children(%) of Middle East & North Africa (all income levels) and Vaccinated children(%) of Peru?
Offer a very short reply. 16.36. In the year 2004, what is the difference between the Vaccinated children(%) of Bangladesh and Vaccinated children(%) of Botswana?
Offer a very short reply. 6. In the year 2004, what is the difference between the Vaccinated children(%) in Bangladesh and Vaccinated children(%) in Peru?
Provide a succinct answer. 24. In the year 2005, what is the difference between the Vaccinated children(%) in Middle East & North Africa (all income levels) and Vaccinated children(%) in Bangladesh?
Offer a very short reply. -9.96. In the year 2005, what is the difference between the Vaccinated children(%) in Middle East & North Africa (all income levels) and Vaccinated children(%) in Botswana?
Your answer should be very brief. -3.96. In the year 2005, what is the difference between the Vaccinated children(%) in Middle East & North Africa (all income levels) and Vaccinated children(%) in Peru?
Your answer should be compact. 14.04. What is the ratio of the Vaccinated children(%) in Middle East & North Africa (all income levels) in 1998 to that in 1999?
Your answer should be very brief. 0.97. What is the ratio of the Vaccinated children(%) in Bangladesh in 1998 to that in 1999?
Provide a short and direct response. 0.99. What is the ratio of the Vaccinated children(%) of Botswana in 1998 to that in 1999?
Your answer should be compact. 0.9. What is the ratio of the Vaccinated children(%) in Peru in 1998 to that in 1999?
Your answer should be compact. 0.98. What is the ratio of the Vaccinated children(%) in Middle East & North Africa (all income levels) in 1998 to that in 2000?
Your response must be concise. 0.9. What is the ratio of the Vaccinated children(%) of Bangladesh in 1998 to that in 2000?
Provide a succinct answer. 0.97. What is the ratio of the Vaccinated children(%) in Peru in 1998 to that in 2000?
Provide a short and direct response. 0.97. What is the ratio of the Vaccinated children(%) in Middle East & North Africa (all income levels) in 1998 to that in 2001?
Provide a short and direct response. 0.88. What is the ratio of the Vaccinated children(%) in Bangladesh in 1998 to that in 2001?
Your answer should be compact. 0.97. What is the ratio of the Vaccinated children(%) of Peru in 1998 to that in 2001?
Give a very brief answer. 1.03. What is the ratio of the Vaccinated children(%) of Middle East & North Africa (all income levels) in 1998 to that in 2002?
Offer a very short reply. 0.86. What is the ratio of the Vaccinated children(%) of Bangladesh in 1998 to that in 2002?
Offer a very short reply. 0.97. What is the ratio of the Vaccinated children(%) in Botswana in 1998 to that in 2002?
Make the answer very short. 0.88. What is the ratio of the Vaccinated children(%) in Peru in 1998 to that in 2002?
Keep it short and to the point. 1.03. What is the ratio of the Vaccinated children(%) in Middle East & North Africa (all income levels) in 1998 to that in 2003?
Your answer should be very brief. 0.85. What is the ratio of the Vaccinated children(%) of Bangladesh in 1998 to that in 2003?
Provide a short and direct response. 0.97. What is the ratio of the Vaccinated children(%) in Botswana in 1998 to that in 2003?
Offer a very short reply. 0.88. What is the ratio of the Vaccinated children(%) of Peru in 1998 to that in 2003?
Ensure brevity in your answer.  1.02. What is the ratio of the Vaccinated children(%) in Middle East & North Africa (all income levels) in 1998 to that in 2004?
Provide a short and direct response. 0.84. What is the ratio of the Vaccinated children(%) of Bangladesh in 1998 to that in 2004?
Offer a terse response. 0.97. What is the ratio of the Vaccinated children(%) of Botswana in 1998 to that in 2004?
Your response must be concise. 0.87. What is the ratio of the Vaccinated children(%) in Peru in 1998 to that in 2004?
Offer a very short reply. 0.98. What is the ratio of the Vaccinated children(%) of Middle East & North Africa (all income levels) in 1998 to that in 2005?
Keep it short and to the point. 0.86. What is the ratio of the Vaccinated children(%) of Bangladesh in 1998 to that in 2005?
Provide a succinct answer. 0.97. What is the ratio of the Vaccinated children(%) in Botswana in 1998 to that in 2005?
Your answer should be compact. 0.87. What is the ratio of the Vaccinated children(%) of Peru in 1998 to that in 2005?
Keep it short and to the point. 0.98. What is the ratio of the Vaccinated children(%) in Middle East & North Africa (all income levels) in 1999 to that in 2000?
Offer a terse response. 0.93. What is the ratio of the Vaccinated children(%) of Bangladesh in 1999 to that in 2000?
Offer a very short reply. 0.98. What is the ratio of the Vaccinated children(%) in Middle East & North Africa (all income levels) in 1999 to that in 2001?
Offer a terse response. 0.9. What is the ratio of the Vaccinated children(%) of Bangladesh in 1999 to that in 2001?
Keep it short and to the point. 0.98. What is the ratio of the Vaccinated children(%) of Peru in 1999 to that in 2001?
Provide a succinct answer. 1.05. What is the ratio of the Vaccinated children(%) of Middle East & North Africa (all income levels) in 1999 to that in 2002?
Give a very brief answer. 0.88. What is the ratio of the Vaccinated children(%) of Bangladesh in 1999 to that in 2002?
Provide a short and direct response. 0.98. What is the ratio of the Vaccinated children(%) of Botswana in 1999 to that in 2002?
Your answer should be very brief. 0.98. What is the ratio of the Vaccinated children(%) of Peru in 1999 to that in 2002?
Make the answer very short. 1.05. What is the ratio of the Vaccinated children(%) of Middle East & North Africa (all income levels) in 1999 to that in 2003?
Make the answer very short. 0.88. What is the ratio of the Vaccinated children(%) in Bangladesh in 1999 to that in 2003?
Keep it short and to the point. 0.98. What is the ratio of the Vaccinated children(%) of Botswana in 1999 to that in 2003?
Your answer should be very brief. 0.98. What is the ratio of the Vaccinated children(%) in Peru in 1999 to that in 2003?
Provide a succinct answer. 1.03. What is the ratio of the Vaccinated children(%) of Middle East & North Africa (all income levels) in 1999 to that in 2004?
Your answer should be very brief. 0.86. What is the ratio of the Vaccinated children(%) in Bangladesh in 1999 to that in 2004?
Provide a succinct answer. 0.98. What is the ratio of the Vaccinated children(%) of Botswana in 1999 to that in 2004?
Keep it short and to the point. 0.96. What is the ratio of the Vaccinated children(%) in Middle East & North Africa (all income levels) in 1999 to that in 2005?
Make the answer very short. 0.89. What is the ratio of the Vaccinated children(%) in Bangladesh in 1999 to that in 2005?
Offer a very short reply. 0.98. What is the ratio of the Vaccinated children(%) in Botswana in 1999 to that in 2005?
Your answer should be very brief. 0.96. What is the ratio of the Vaccinated children(%) in Peru in 1999 to that in 2005?
Make the answer very short. 1. What is the ratio of the Vaccinated children(%) in Middle East & North Africa (all income levels) in 2000 to that in 2001?
Provide a succinct answer. 0.97. What is the ratio of the Vaccinated children(%) in Bangladesh in 2000 to that in 2001?
Keep it short and to the point. 1. What is the ratio of the Vaccinated children(%) of Peru in 2000 to that in 2001?
Offer a very short reply. 1.06. What is the ratio of the Vaccinated children(%) of Middle East & North Africa (all income levels) in 2000 to that in 2002?
Your response must be concise. 0.95. What is the ratio of the Vaccinated children(%) in Bangladesh in 2000 to that in 2002?
Your answer should be very brief. 1. What is the ratio of the Vaccinated children(%) in Botswana in 2000 to that in 2002?
Give a very brief answer. 0.98. What is the ratio of the Vaccinated children(%) of Peru in 2000 to that in 2002?
Give a very brief answer. 1.06. What is the ratio of the Vaccinated children(%) in Middle East & North Africa (all income levels) in 2000 to that in 2003?
Provide a succinct answer. 0.95. What is the ratio of the Vaccinated children(%) of Bangladesh in 2000 to that in 2003?
Give a very brief answer. 1. What is the ratio of the Vaccinated children(%) in Botswana in 2000 to that in 2003?
Provide a succinct answer. 0.98. What is the ratio of the Vaccinated children(%) of Peru in 2000 to that in 2003?
Give a very brief answer. 1.05. What is the ratio of the Vaccinated children(%) of Middle East & North Africa (all income levels) in 2000 to that in 2004?
Your response must be concise. 0.93. What is the ratio of the Vaccinated children(%) of Bangladesh in 2000 to that in 2004?
Your answer should be very brief. 1. What is the ratio of the Vaccinated children(%) in Botswana in 2000 to that in 2004?
Your answer should be very brief. 0.96. What is the ratio of the Vaccinated children(%) of Peru in 2000 to that in 2004?
Your answer should be very brief. 1.02. What is the ratio of the Vaccinated children(%) of Middle East & North Africa (all income levels) in 2000 to that in 2005?
Your answer should be very brief. 0.96. What is the ratio of the Vaccinated children(%) of Botswana in 2000 to that in 2005?
Offer a terse response. 0.96. What is the ratio of the Vaccinated children(%) in Peru in 2000 to that in 2005?
Your answer should be very brief. 1.02. What is the ratio of the Vaccinated children(%) in Middle East & North Africa (all income levels) in 2001 to that in 2002?
Provide a short and direct response. 0.98. What is the ratio of the Vaccinated children(%) in Botswana in 2001 to that in 2002?
Make the answer very short. 0.99. What is the ratio of the Vaccinated children(%) in Middle East & North Africa (all income levels) in 2001 to that in 2003?
Give a very brief answer. 0.98. What is the ratio of the Vaccinated children(%) of Botswana in 2001 to that in 2003?
Your response must be concise. 0.99. What is the ratio of the Vaccinated children(%) of Peru in 2001 to that in 2003?
Your answer should be very brief. 0.98. What is the ratio of the Vaccinated children(%) in Middle East & North Africa (all income levels) in 2001 to that in 2004?
Your answer should be compact. 0.96. What is the ratio of the Vaccinated children(%) in Botswana in 2001 to that in 2004?
Provide a short and direct response. 0.98. What is the ratio of the Vaccinated children(%) in Peru in 2001 to that in 2004?
Offer a very short reply. 0.95. What is the ratio of the Vaccinated children(%) of Middle East & North Africa (all income levels) in 2001 to that in 2005?
Ensure brevity in your answer.  0.98. What is the ratio of the Vaccinated children(%) of Botswana in 2001 to that in 2005?
Make the answer very short. 0.98. What is the ratio of the Vaccinated children(%) of Peru in 2001 to that in 2005?
Offer a very short reply. 0.95. What is the ratio of the Vaccinated children(%) in Middle East & North Africa (all income levels) in 2002 to that in 2003?
Offer a very short reply. 1. What is the ratio of the Vaccinated children(%) of Bangladesh in 2002 to that in 2003?
Provide a succinct answer. 1. What is the ratio of the Vaccinated children(%) in Peru in 2002 to that in 2003?
Your answer should be very brief. 0.98. What is the ratio of the Vaccinated children(%) of Middle East & North Africa (all income levels) in 2002 to that in 2004?
Your answer should be very brief. 0.98. What is the ratio of the Vaccinated children(%) in Bangladesh in 2002 to that in 2004?
Offer a very short reply. 1. What is the ratio of the Vaccinated children(%) in Peru in 2002 to that in 2004?
Offer a very short reply. 0.95. What is the ratio of the Vaccinated children(%) of Middle East & North Africa (all income levels) in 2002 to that in 2005?
Your answer should be compact. 1.01. What is the ratio of the Vaccinated children(%) in Bangladesh in 2002 to that in 2005?
Keep it short and to the point. 1. What is the ratio of the Vaccinated children(%) in Peru in 2002 to that in 2005?
Ensure brevity in your answer.  0.95. What is the ratio of the Vaccinated children(%) of Middle East & North Africa (all income levels) in 2003 to that in 2004?
Make the answer very short. 0.98. What is the ratio of the Vaccinated children(%) in Peru in 2003 to that in 2004?
Offer a terse response. 0.97. What is the ratio of the Vaccinated children(%) of Middle East & North Africa (all income levels) in 2003 to that in 2005?
Ensure brevity in your answer.  1.01. What is the ratio of the Vaccinated children(%) in Bangladesh in 2003 to that in 2005?
Keep it short and to the point. 1. What is the ratio of the Vaccinated children(%) of Peru in 2003 to that in 2005?
Give a very brief answer. 0.97. What is the ratio of the Vaccinated children(%) in Middle East & North Africa (all income levels) in 2004 to that in 2005?
Your answer should be very brief. 1.03. What is the ratio of the Vaccinated children(%) of Peru in 2004 to that in 2005?
Offer a very short reply. 1. What is the difference between the highest and the second highest Vaccinated children(%) of Middle East & North Africa (all income levels)?
Make the answer very short. 1.64. What is the difference between the highest and the second highest Vaccinated children(%) of Bangladesh?
Your answer should be very brief. 0. What is the difference between the highest and the second highest Vaccinated children(%) in Peru?
Your answer should be very brief. 1. What is the difference between the highest and the lowest Vaccinated children(%) in Middle East & North Africa (all income levels)?
Your response must be concise. 13.21. What is the difference between the highest and the lowest Vaccinated children(%) of Bangladesh?
Your response must be concise. 3. What is the difference between the highest and the lowest Vaccinated children(%) in Botswana?
Offer a very short reply. 11. What is the difference between the highest and the lowest Vaccinated children(%) of Peru?
Ensure brevity in your answer.  4. 